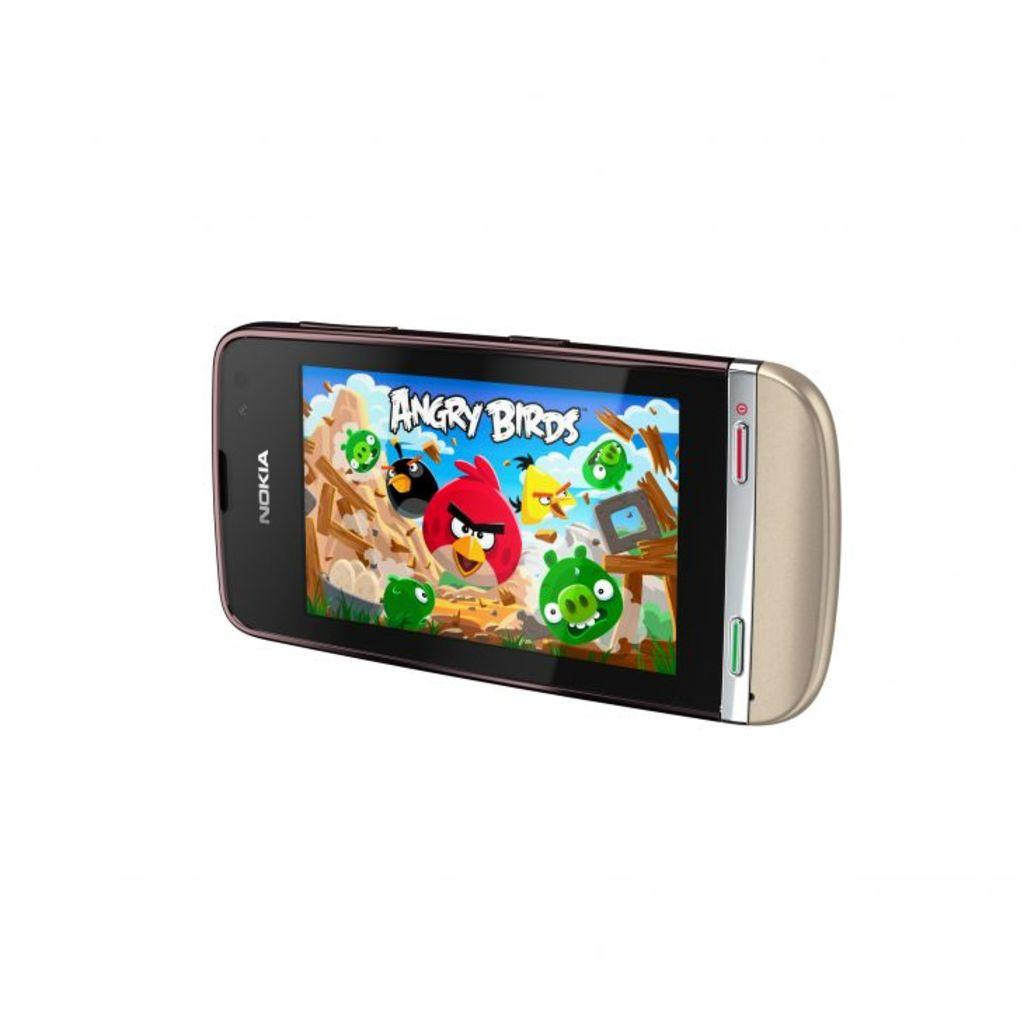<image>
Share a concise interpretation of the image provided. The game Angry Birds is visible on the screen of a Nokia cell phone. 